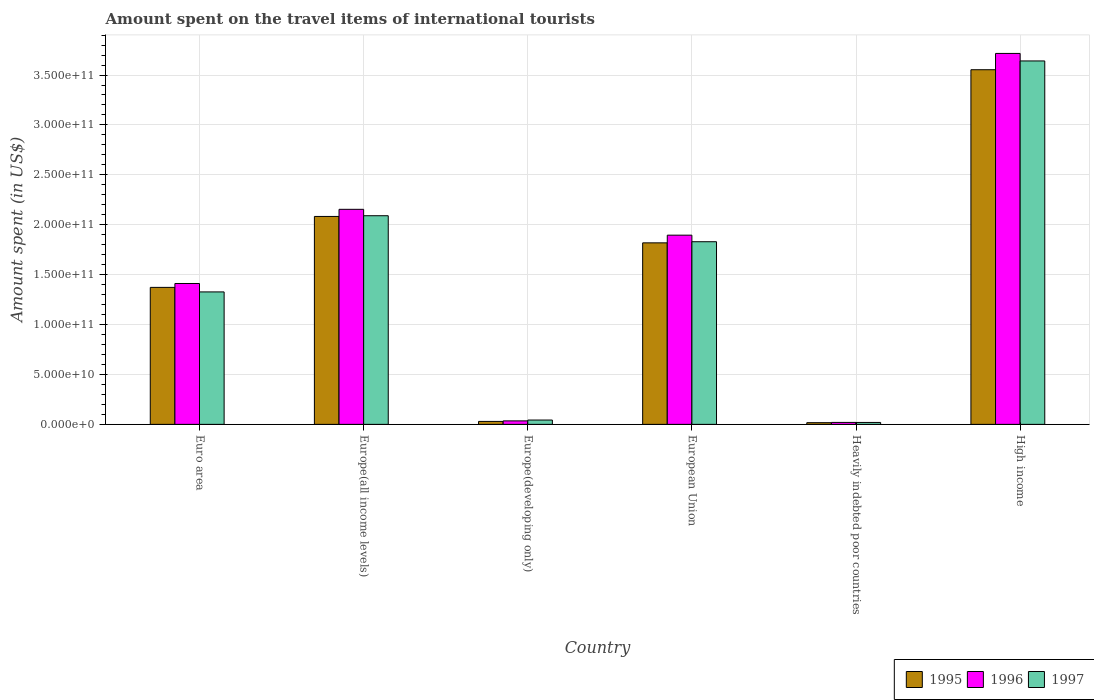How many different coloured bars are there?
Keep it short and to the point. 3. How many groups of bars are there?
Offer a very short reply. 6. How many bars are there on the 3rd tick from the right?
Offer a terse response. 3. In how many cases, is the number of bars for a given country not equal to the number of legend labels?
Keep it short and to the point. 0. What is the amount spent on the travel items of international tourists in 1995 in European Union?
Offer a very short reply. 1.82e+11. Across all countries, what is the maximum amount spent on the travel items of international tourists in 1996?
Offer a very short reply. 3.72e+11. Across all countries, what is the minimum amount spent on the travel items of international tourists in 1997?
Provide a succinct answer. 1.94e+09. In which country was the amount spent on the travel items of international tourists in 1996 maximum?
Provide a short and direct response. High income. In which country was the amount spent on the travel items of international tourists in 1996 minimum?
Your answer should be compact. Heavily indebted poor countries. What is the total amount spent on the travel items of international tourists in 1997 in the graph?
Your answer should be compact. 8.95e+11. What is the difference between the amount spent on the travel items of international tourists in 1997 in Europe(developing only) and that in European Union?
Your answer should be compact. -1.79e+11. What is the difference between the amount spent on the travel items of international tourists in 1995 in Europe(developing only) and the amount spent on the travel items of international tourists in 1996 in Europe(all income levels)?
Make the answer very short. -2.12e+11. What is the average amount spent on the travel items of international tourists in 1995 per country?
Make the answer very short. 1.48e+11. What is the difference between the amount spent on the travel items of international tourists of/in 1996 and amount spent on the travel items of international tourists of/in 1997 in Euro area?
Ensure brevity in your answer.  8.44e+09. What is the ratio of the amount spent on the travel items of international tourists in 1995 in Euro area to that in Europe(developing only)?
Provide a short and direct response. 46.21. What is the difference between the highest and the second highest amount spent on the travel items of international tourists in 1995?
Ensure brevity in your answer.  -1.73e+11. What is the difference between the highest and the lowest amount spent on the travel items of international tourists in 1995?
Give a very brief answer. 3.54e+11. Is the sum of the amount spent on the travel items of international tourists in 1996 in Europe(all income levels) and Heavily indebted poor countries greater than the maximum amount spent on the travel items of international tourists in 1997 across all countries?
Your answer should be very brief. No. What does the 1st bar from the left in Europe(all income levels) represents?
Offer a terse response. 1995. What does the 3rd bar from the right in High income represents?
Your answer should be compact. 1995. Is it the case that in every country, the sum of the amount spent on the travel items of international tourists in 1997 and amount spent on the travel items of international tourists in 1995 is greater than the amount spent on the travel items of international tourists in 1996?
Offer a very short reply. Yes. How many bars are there?
Make the answer very short. 18. How many countries are there in the graph?
Make the answer very short. 6. Does the graph contain any zero values?
Make the answer very short. No. Where does the legend appear in the graph?
Your answer should be compact. Bottom right. What is the title of the graph?
Keep it short and to the point. Amount spent on the travel items of international tourists. What is the label or title of the X-axis?
Offer a very short reply. Country. What is the label or title of the Y-axis?
Your answer should be very brief. Amount spent (in US$). What is the Amount spent (in US$) of 1995 in Euro area?
Offer a very short reply. 1.37e+11. What is the Amount spent (in US$) in 1996 in Euro area?
Ensure brevity in your answer.  1.41e+11. What is the Amount spent (in US$) of 1997 in Euro area?
Offer a terse response. 1.33e+11. What is the Amount spent (in US$) in 1995 in Europe(all income levels)?
Offer a very short reply. 2.08e+11. What is the Amount spent (in US$) in 1996 in Europe(all income levels)?
Your response must be concise. 2.15e+11. What is the Amount spent (in US$) of 1997 in Europe(all income levels)?
Ensure brevity in your answer.  2.09e+11. What is the Amount spent (in US$) of 1995 in Europe(developing only)?
Your answer should be compact. 2.97e+09. What is the Amount spent (in US$) of 1996 in Europe(developing only)?
Provide a short and direct response. 3.49e+09. What is the Amount spent (in US$) in 1997 in Europe(developing only)?
Keep it short and to the point. 4.34e+09. What is the Amount spent (in US$) in 1995 in European Union?
Offer a very short reply. 1.82e+11. What is the Amount spent (in US$) of 1996 in European Union?
Offer a very short reply. 1.90e+11. What is the Amount spent (in US$) in 1997 in European Union?
Keep it short and to the point. 1.83e+11. What is the Amount spent (in US$) of 1995 in Heavily indebted poor countries?
Make the answer very short. 1.70e+09. What is the Amount spent (in US$) in 1996 in Heavily indebted poor countries?
Give a very brief answer. 1.97e+09. What is the Amount spent (in US$) in 1997 in Heavily indebted poor countries?
Provide a short and direct response. 1.94e+09. What is the Amount spent (in US$) of 1995 in High income?
Offer a very short reply. 3.55e+11. What is the Amount spent (in US$) in 1996 in High income?
Keep it short and to the point. 3.72e+11. What is the Amount spent (in US$) of 1997 in High income?
Offer a very short reply. 3.64e+11. Across all countries, what is the maximum Amount spent (in US$) in 1995?
Your response must be concise. 3.55e+11. Across all countries, what is the maximum Amount spent (in US$) in 1996?
Offer a terse response. 3.72e+11. Across all countries, what is the maximum Amount spent (in US$) of 1997?
Your response must be concise. 3.64e+11. Across all countries, what is the minimum Amount spent (in US$) in 1995?
Your response must be concise. 1.70e+09. Across all countries, what is the minimum Amount spent (in US$) in 1996?
Offer a very short reply. 1.97e+09. Across all countries, what is the minimum Amount spent (in US$) of 1997?
Offer a very short reply. 1.94e+09. What is the total Amount spent (in US$) in 1995 in the graph?
Provide a succinct answer. 8.87e+11. What is the total Amount spent (in US$) in 1996 in the graph?
Provide a succinct answer. 9.23e+11. What is the total Amount spent (in US$) of 1997 in the graph?
Keep it short and to the point. 8.95e+11. What is the difference between the Amount spent (in US$) in 1995 in Euro area and that in Europe(all income levels)?
Offer a very short reply. -7.11e+1. What is the difference between the Amount spent (in US$) in 1996 in Euro area and that in Europe(all income levels)?
Make the answer very short. -7.43e+1. What is the difference between the Amount spent (in US$) of 1997 in Euro area and that in Europe(all income levels)?
Ensure brevity in your answer.  -7.63e+1. What is the difference between the Amount spent (in US$) of 1995 in Euro area and that in Europe(developing only)?
Ensure brevity in your answer.  1.34e+11. What is the difference between the Amount spent (in US$) of 1996 in Euro area and that in Europe(developing only)?
Offer a terse response. 1.38e+11. What is the difference between the Amount spent (in US$) in 1997 in Euro area and that in Europe(developing only)?
Provide a short and direct response. 1.28e+11. What is the difference between the Amount spent (in US$) of 1995 in Euro area and that in European Union?
Offer a terse response. -4.46e+1. What is the difference between the Amount spent (in US$) in 1996 in Euro area and that in European Union?
Ensure brevity in your answer.  -4.84e+1. What is the difference between the Amount spent (in US$) in 1997 in Euro area and that in European Union?
Provide a short and direct response. -5.03e+1. What is the difference between the Amount spent (in US$) in 1995 in Euro area and that in Heavily indebted poor countries?
Your answer should be compact. 1.36e+11. What is the difference between the Amount spent (in US$) of 1996 in Euro area and that in Heavily indebted poor countries?
Your answer should be compact. 1.39e+11. What is the difference between the Amount spent (in US$) of 1997 in Euro area and that in Heavily indebted poor countries?
Your answer should be compact. 1.31e+11. What is the difference between the Amount spent (in US$) in 1995 in Euro area and that in High income?
Provide a succinct answer. -2.18e+11. What is the difference between the Amount spent (in US$) in 1996 in Euro area and that in High income?
Offer a very short reply. -2.30e+11. What is the difference between the Amount spent (in US$) in 1997 in Euro area and that in High income?
Provide a short and direct response. -2.31e+11. What is the difference between the Amount spent (in US$) in 1995 in Europe(all income levels) and that in Europe(developing only)?
Offer a terse response. 2.05e+11. What is the difference between the Amount spent (in US$) in 1996 in Europe(all income levels) and that in Europe(developing only)?
Provide a succinct answer. 2.12e+11. What is the difference between the Amount spent (in US$) of 1997 in Europe(all income levels) and that in Europe(developing only)?
Provide a succinct answer. 2.05e+11. What is the difference between the Amount spent (in US$) in 1995 in Europe(all income levels) and that in European Union?
Your answer should be very brief. 2.65e+1. What is the difference between the Amount spent (in US$) in 1996 in Europe(all income levels) and that in European Union?
Provide a succinct answer. 2.59e+1. What is the difference between the Amount spent (in US$) of 1997 in Europe(all income levels) and that in European Union?
Provide a short and direct response. 2.61e+1. What is the difference between the Amount spent (in US$) of 1995 in Europe(all income levels) and that in Heavily indebted poor countries?
Provide a short and direct response. 2.07e+11. What is the difference between the Amount spent (in US$) in 1996 in Europe(all income levels) and that in Heavily indebted poor countries?
Offer a very short reply. 2.13e+11. What is the difference between the Amount spent (in US$) of 1997 in Europe(all income levels) and that in Heavily indebted poor countries?
Give a very brief answer. 2.07e+11. What is the difference between the Amount spent (in US$) in 1995 in Europe(all income levels) and that in High income?
Offer a very short reply. -1.47e+11. What is the difference between the Amount spent (in US$) of 1996 in Europe(all income levels) and that in High income?
Give a very brief answer. -1.56e+11. What is the difference between the Amount spent (in US$) of 1997 in Europe(all income levels) and that in High income?
Give a very brief answer. -1.55e+11. What is the difference between the Amount spent (in US$) in 1995 in Europe(developing only) and that in European Union?
Offer a very short reply. -1.79e+11. What is the difference between the Amount spent (in US$) in 1996 in Europe(developing only) and that in European Union?
Your response must be concise. -1.86e+11. What is the difference between the Amount spent (in US$) in 1997 in Europe(developing only) and that in European Union?
Your answer should be compact. -1.79e+11. What is the difference between the Amount spent (in US$) in 1995 in Europe(developing only) and that in Heavily indebted poor countries?
Keep it short and to the point. 1.27e+09. What is the difference between the Amount spent (in US$) in 1996 in Europe(developing only) and that in Heavily indebted poor countries?
Your answer should be very brief. 1.53e+09. What is the difference between the Amount spent (in US$) in 1997 in Europe(developing only) and that in Heavily indebted poor countries?
Ensure brevity in your answer.  2.41e+09. What is the difference between the Amount spent (in US$) of 1995 in Europe(developing only) and that in High income?
Keep it short and to the point. -3.52e+11. What is the difference between the Amount spent (in US$) of 1996 in Europe(developing only) and that in High income?
Keep it short and to the point. -3.68e+11. What is the difference between the Amount spent (in US$) of 1997 in Europe(developing only) and that in High income?
Your answer should be very brief. -3.60e+11. What is the difference between the Amount spent (in US$) in 1995 in European Union and that in Heavily indebted poor countries?
Give a very brief answer. 1.80e+11. What is the difference between the Amount spent (in US$) of 1996 in European Union and that in Heavily indebted poor countries?
Offer a terse response. 1.88e+11. What is the difference between the Amount spent (in US$) of 1997 in European Union and that in Heavily indebted poor countries?
Provide a succinct answer. 1.81e+11. What is the difference between the Amount spent (in US$) in 1995 in European Union and that in High income?
Ensure brevity in your answer.  -1.73e+11. What is the difference between the Amount spent (in US$) in 1996 in European Union and that in High income?
Your answer should be very brief. -1.82e+11. What is the difference between the Amount spent (in US$) in 1997 in European Union and that in High income?
Your answer should be compact. -1.81e+11. What is the difference between the Amount spent (in US$) in 1995 in Heavily indebted poor countries and that in High income?
Give a very brief answer. -3.54e+11. What is the difference between the Amount spent (in US$) in 1996 in Heavily indebted poor countries and that in High income?
Make the answer very short. -3.70e+11. What is the difference between the Amount spent (in US$) of 1997 in Heavily indebted poor countries and that in High income?
Make the answer very short. -3.62e+11. What is the difference between the Amount spent (in US$) of 1995 in Euro area and the Amount spent (in US$) of 1996 in Europe(all income levels)?
Your answer should be compact. -7.82e+1. What is the difference between the Amount spent (in US$) of 1995 in Euro area and the Amount spent (in US$) of 1997 in Europe(all income levels)?
Provide a succinct answer. -7.18e+1. What is the difference between the Amount spent (in US$) in 1996 in Euro area and the Amount spent (in US$) in 1997 in Europe(all income levels)?
Your response must be concise. -6.79e+1. What is the difference between the Amount spent (in US$) in 1995 in Euro area and the Amount spent (in US$) in 1996 in Europe(developing only)?
Provide a succinct answer. 1.34e+11. What is the difference between the Amount spent (in US$) in 1995 in Euro area and the Amount spent (in US$) in 1997 in Europe(developing only)?
Provide a short and direct response. 1.33e+11. What is the difference between the Amount spent (in US$) in 1996 in Euro area and the Amount spent (in US$) in 1997 in Europe(developing only)?
Provide a short and direct response. 1.37e+11. What is the difference between the Amount spent (in US$) of 1995 in Euro area and the Amount spent (in US$) of 1996 in European Union?
Your answer should be compact. -5.23e+1. What is the difference between the Amount spent (in US$) in 1995 in Euro area and the Amount spent (in US$) in 1997 in European Union?
Your answer should be compact. -4.57e+1. What is the difference between the Amount spent (in US$) in 1996 in Euro area and the Amount spent (in US$) in 1997 in European Union?
Provide a succinct answer. -4.18e+1. What is the difference between the Amount spent (in US$) in 1995 in Euro area and the Amount spent (in US$) in 1996 in Heavily indebted poor countries?
Offer a terse response. 1.35e+11. What is the difference between the Amount spent (in US$) of 1995 in Euro area and the Amount spent (in US$) of 1997 in Heavily indebted poor countries?
Make the answer very short. 1.35e+11. What is the difference between the Amount spent (in US$) of 1996 in Euro area and the Amount spent (in US$) of 1997 in Heavily indebted poor countries?
Your answer should be compact. 1.39e+11. What is the difference between the Amount spent (in US$) of 1995 in Euro area and the Amount spent (in US$) of 1996 in High income?
Offer a very short reply. -2.34e+11. What is the difference between the Amount spent (in US$) of 1995 in Euro area and the Amount spent (in US$) of 1997 in High income?
Ensure brevity in your answer.  -2.27e+11. What is the difference between the Amount spent (in US$) in 1996 in Euro area and the Amount spent (in US$) in 1997 in High income?
Your answer should be very brief. -2.23e+11. What is the difference between the Amount spent (in US$) of 1995 in Europe(all income levels) and the Amount spent (in US$) of 1996 in Europe(developing only)?
Offer a terse response. 2.05e+11. What is the difference between the Amount spent (in US$) in 1995 in Europe(all income levels) and the Amount spent (in US$) in 1997 in Europe(developing only)?
Your answer should be compact. 2.04e+11. What is the difference between the Amount spent (in US$) in 1996 in Europe(all income levels) and the Amount spent (in US$) in 1997 in Europe(developing only)?
Make the answer very short. 2.11e+11. What is the difference between the Amount spent (in US$) in 1995 in Europe(all income levels) and the Amount spent (in US$) in 1996 in European Union?
Keep it short and to the point. 1.88e+1. What is the difference between the Amount spent (in US$) of 1995 in Europe(all income levels) and the Amount spent (in US$) of 1997 in European Union?
Offer a terse response. 2.53e+1. What is the difference between the Amount spent (in US$) in 1996 in Europe(all income levels) and the Amount spent (in US$) in 1997 in European Union?
Offer a very short reply. 3.25e+1. What is the difference between the Amount spent (in US$) of 1995 in Europe(all income levels) and the Amount spent (in US$) of 1996 in Heavily indebted poor countries?
Make the answer very short. 2.06e+11. What is the difference between the Amount spent (in US$) of 1995 in Europe(all income levels) and the Amount spent (in US$) of 1997 in Heavily indebted poor countries?
Your response must be concise. 2.06e+11. What is the difference between the Amount spent (in US$) of 1996 in Europe(all income levels) and the Amount spent (in US$) of 1997 in Heavily indebted poor countries?
Your answer should be very brief. 2.14e+11. What is the difference between the Amount spent (in US$) of 1995 in Europe(all income levels) and the Amount spent (in US$) of 1996 in High income?
Your answer should be very brief. -1.63e+11. What is the difference between the Amount spent (in US$) in 1995 in Europe(all income levels) and the Amount spent (in US$) in 1997 in High income?
Give a very brief answer. -1.56e+11. What is the difference between the Amount spent (in US$) of 1996 in Europe(all income levels) and the Amount spent (in US$) of 1997 in High income?
Provide a succinct answer. -1.49e+11. What is the difference between the Amount spent (in US$) of 1995 in Europe(developing only) and the Amount spent (in US$) of 1996 in European Union?
Your response must be concise. -1.87e+11. What is the difference between the Amount spent (in US$) of 1995 in Europe(developing only) and the Amount spent (in US$) of 1997 in European Union?
Your response must be concise. -1.80e+11. What is the difference between the Amount spent (in US$) of 1996 in Europe(developing only) and the Amount spent (in US$) of 1997 in European Union?
Keep it short and to the point. -1.79e+11. What is the difference between the Amount spent (in US$) in 1995 in Europe(developing only) and the Amount spent (in US$) in 1996 in Heavily indebted poor countries?
Offer a terse response. 1.00e+09. What is the difference between the Amount spent (in US$) of 1995 in Europe(developing only) and the Amount spent (in US$) of 1997 in Heavily indebted poor countries?
Your answer should be very brief. 1.03e+09. What is the difference between the Amount spent (in US$) in 1996 in Europe(developing only) and the Amount spent (in US$) in 1997 in Heavily indebted poor countries?
Provide a succinct answer. 1.56e+09. What is the difference between the Amount spent (in US$) in 1995 in Europe(developing only) and the Amount spent (in US$) in 1996 in High income?
Offer a very short reply. -3.69e+11. What is the difference between the Amount spent (in US$) in 1995 in Europe(developing only) and the Amount spent (in US$) in 1997 in High income?
Give a very brief answer. -3.61e+11. What is the difference between the Amount spent (in US$) in 1996 in Europe(developing only) and the Amount spent (in US$) in 1997 in High income?
Your answer should be very brief. -3.61e+11. What is the difference between the Amount spent (in US$) of 1995 in European Union and the Amount spent (in US$) of 1996 in Heavily indebted poor countries?
Make the answer very short. 1.80e+11. What is the difference between the Amount spent (in US$) in 1995 in European Union and the Amount spent (in US$) in 1997 in Heavily indebted poor countries?
Offer a very short reply. 1.80e+11. What is the difference between the Amount spent (in US$) in 1996 in European Union and the Amount spent (in US$) in 1997 in Heavily indebted poor countries?
Make the answer very short. 1.88e+11. What is the difference between the Amount spent (in US$) of 1995 in European Union and the Amount spent (in US$) of 1996 in High income?
Your response must be concise. -1.90e+11. What is the difference between the Amount spent (in US$) in 1995 in European Union and the Amount spent (in US$) in 1997 in High income?
Your answer should be very brief. -1.82e+11. What is the difference between the Amount spent (in US$) of 1996 in European Union and the Amount spent (in US$) of 1997 in High income?
Keep it short and to the point. -1.75e+11. What is the difference between the Amount spent (in US$) of 1995 in Heavily indebted poor countries and the Amount spent (in US$) of 1996 in High income?
Provide a short and direct response. -3.70e+11. What is the difference between the Amount spent (in US$) in 1995 in Heavily indebted poor countries and the Amount spent (in US$) in 1997 in High income?
Give a very brief answer. -3.62e+11. What is the difference between the Amount spent (in US$) in 1996 in Heavily indebted poor countries and the Amount spent (in US$) in 1997 in High income?
Keep it short and to the point. -3.62e+11. What is the average Amount spent (in US$) of 1995 per country?
Provide a short and direct response. 1.48e+11. What is the average Amount spent (in US$) of 1996 per country?
Keep it short and to the point. 1.54e+11. What is the average Amount spent (in US$) of 1997 per country?
Give a very brief answer. 1.49e+11. What is the difference between the Amount spent (in US$) of 1995 and Amount spent (in US$) of 1996 in Euro area?
Your answer should be compact. -3.90e+09. What is the difference between the Amount spent (in US$) in 1995 and Amount spent (in US$) in 1997 in Euro area?
Offer a terse response. 4.54e+09. What is the difference between the Amount spent (in US$) of 1996 and Amount spent (in US$) of 1997 in Euro area?
Your answer should be compact. 8.44e+09. What is the difference between the Amount spent (in US$) in 1995 and Amount spent (in US$) in 1996 in Europe(all income levels)?
Provide a short and direct response. -7.14e+09. What is the difference between the Amount spent (in US$) in 1995 and Amount spent (in US$) in 1997 in Europe(all income levels)?
Make the answer very short. -7.16e+08. What is the difference between the Amount spent (in US$) in 1996 and Amount spent (in US$) in 1997 in Europe(all income levels)?
Keep it short and to the point. 6.43e+09. What is the difference between the Amount spent (in US$) of 1995 and Amount spent (in US$) of 1996 in Europe(developing only)?
Your response must be concise. -5.24e+08. What is the difference between the Amount spent (in US$) of 1995 and Amount spent (in US$) of 1997 in Europe(developing only)?
Give a very brief answer. -1.37e+09. What is the difference between the Amount spent (in US$) of 1996 and Amount spent (in US$) of 1997 in Europe(developing only)?
Make the answer very short. -8.50e+08. What is the difference between the Amount spent (in US$) of 1995 and Amount spent (in US$) of 1996 in European Union?
Offer a terse response. -7.70e+09. What is the difference between the Amount spent (in US$) of 1995 and Amount spent (in US$) of 1997 in European Union?
Make the answer very short. -1.12e+09. What is the difference between the Amount spent (in US$) in 1996 and Amount spent (in US$) in 1997 in European Union?
Offer a very short reply. 6.58e+09. What is the difference between the Amount spent (in US$) in 1995 and Amount spent (in US$) in 1996 in Heavily indebted poor countries?
Your response must be concise. -2.62e+08. What is the difference between the Amount spent (in US$) of 1995 and Amount spent (in US$) of 1997 in Heavily indebted poor countries?
Offer a very short reply. -2.36e+08. What is the difference between the Amount spent (in US$) in 1996 and Amount spent (in US$) in 1997 in Heavily indebted poor countries?
Ensure brevity in your answer.  2.65e+07. What is the difference between the Amount spent (in US$) in 1995 and Amount spent (in US$) in 1996 in High income?
Offer a terse response. -1.63e+1. What is the difference between the Amount spent (in US$) in 1995 and Amount spent (in US$) in 1997 in High income?
Offer a terse response. -8.79e+09. What is the difference between the Amount spent (in US$) of 1996 and Amount spent (in US$) of 1997 in High income?
Your answer should be compact. 7.54e+09. What is the ratio of the Amount spent (in US$) of 1995 in Euro area to that in Europe(all income levels)?
Give a very brief answer. 0.66. What is the ratio of the Amount spent (in US$) of 1996 in Euro area to that in Europe(all income levels)?
Ensure brevity in your answer.  0.66. What is the ratio of the Amount spent (in US$) of 1997 in Euro area to that in Europe(all income levels)?
Keep it short and to the point. 0.63. What is the ratio of the Amount spent (in US$) of 1995 in Euro area to that in Europe(developing only)?
Offer a very short reply. 46.21. What is the ratio of the Amount spent (in US$) in 1996 in Euro area to that in Europe(developing only)?
Provide a short and direct response. 40.39. What is the ratio of the Amount spent (in US$) in 1997 in Euro area to that in Europe(developing only)?
Your answer should be compact. 30.55. What is the ratio of the Amount spent (in US$) of 1995 in Euro area to that in European Union?
Ensure brevity in your answer.  0.75. What is the ratio of the Amount spent (in US$) in 1996 in Euro area to that in European Union?
Give a very brief answer. 0.74. What is the ratio of the Amount spent (in US$) in 1997 in Euro area to that in European Union?
Keep it short and to the point. 0.73. What is the ratio of the Amount spent (in US$) in 1995 in Euro area to that in Heavily indebted poor countries?
Give a very brief answer. 80.55. What is the ratio of the Amount spent (in US$) in 1996 in Euro area to that in Heavily indebted poor countries?
Ensure brevity in your answer.  71.8. What is the ratio of the Amount spent (in US$) of 1997 in Euro area to that in Heavily indebted poor countries?
Give a very brief answer. 68.43. What is the ratio of the Amount spent (in US$) in 1995 in Euro area to that in High income?
Give a very brief answer. 0.39. What is the ratio of the Amount spent (in US$) of 1996 in Euro area to that in High income?
Provide a succinct answer. 0.38. What is the ratio of the Amount spent (in US$) of 1997 in Euro area to that in High income?
Your answer should be very brief. 0.36. What is the ratio of the Amount spent (in US$) in 1995 in Europe(all income levels) to that in Europe(developing only)?
Provide a succinct answer. 70.13. What is the ratio of the Amount spent (in US$) in 1996 in Europe(all income levels) to that in Europe(developing only)?
Provide a short and direct response. 61.65. What is the ratio of the Amount spent (in US$) of 1997 in Europe(all income levels) to that in Europe(developing only)?
Your answer should be very brief. 48.11. What is the ratio of the Amount spent (in US$) in 1995 in Europe(all income levels) to that in European Union?
Provide a short and direct response. 1.15. What is the ratio of the Amount spent (in US$) of 1996 in Europe(all income levels) to that in European Union?
Your answer should be compact. 1.14. What is the ratio of the Amount spent (in US$) in 1997 in Europe(all income levels) to that in European Union?
Ensure brevity in your answer.  1.14. What is the ratio of the Amount spent (in US$) of 1995 in Europe(all income levels) to that in Heavily indebted poor countries?
Your answer should be compact. 122.26. What is the ratio of the Amount spent (in US$) in 1996 in Europe(all income levels) to that in Heavily indebted poor countries?
Your answer should be very brief. 109.59. What is the ratio of the Amount spent (in US$) of 1997 in Europe(all income levels) to that in Heavily indebted poor countries?
Your response must be concise. 107.78. What is the ratio of the Amount spent (in US$) of 1995 in Europe(all income levels) to that in High income?
Your response must be concise. 0.59. What is the ratio of the Amount spent (in US$) of 1996 in Europe(all income levels) to that in High income?
Give a very brief answer. 0.58. What is the ratio of the Amount spent (in US$) of 1997 in Europe(all income levels) to that in High income?
Keep it short and to the point. 0.57. What is the ratio of the Amount spent (in US$) of 1995 in Europe(developing only) to that in European Union?
Give a very brief answer. 0.02. What is the ratio of the Amount spent (in US$) in 1996 in Europe(developing only) to that in European Union?
Ensure brevity in your answer.  0.02. What is the ratio of the Amount spent (in US$) of 1997 in Europe(developing only) to that in European Union?
Give a very brief answer. 0.02. What is the ratio of the Amount spent (in US$) in 1995 in Europe(developing only) to that in Heavily indebted poor countries?
Ensure brevity in your answer.  1.74. What is the ratio of the Amount spent (in US$) of 1996 in Europe(developing only) to that in Heavily indebted poor countries?
Your answer should be compact. 1.78. What is the ratio of the Amount spent (in US$) of 1997 in Europe(developing only) to that in Heavily indebted poor countries?
Your answer should be compact. 2.24. What is the ratio of the Amount spent (in US$) in 1995 in Europe(developing only) to that in High income?
Your answer should be very brief. 0.01. What is the ratio of the Amount spent (in US$) of 1996 in Europe(developing only) to that in High income?
Offer a terse response. 0.01. What is the ratio of the Amount spent (in US$) of 1997 in Europe(developing only) to that in High income?
Your answer should be compact. 0.01. What is the ratio of the Amount spent (in US$) in 1995 in European Union to that in Heavily indebted poor countries?
Give a very brief answer. 106.73. What is the ratio of the Amount spent (in US$) in 1996 in European Union to that in Heavily indebted poor countries?
Provide a short and direct response. 96.42. What is the ratio of the Amount spent (in US$) of 1997 in European Union to that in Heavily indebted poor countries?
Make the answer very short. 94.35. What is the ratio of the Amount spent (in US$) in 1995 in European Union to that in High income?
Offer a very short reply. 0.51. What is the ratio of the Amount spent (in US$) of 1996 in European Union to that in High income?
Keep it short and to the point. 0.51. What is the ratio of the Amount spent (in US$) of 1997 in European Union to that in High income?
Provide a succinct answer. 0.5. What is the ratio of the Amount spent (in US$) in 1995 in Heavily indebted poor countries to that in High income?
Offer a terse response. 0. What is the ratio of the Amount spent (in US$) of 1996 in Heavily indebted poor countries to that in High income?
Provide a short and direct response. 0.01. What is the ratio of the Amount spent (in US$) of 1997 in Heavily indebted poor countries to that in High income?
Provide a short and direct response. 0.01. What is the difference between the highest and the second highest Amount spent (in US$) in 1995?
Give a very brief answer. 1.47e+11. What is the difference between the highest and the second highest Amount spent (in US$) in 1996?
Your response must be concise. 1.56e+11. What is the difference between the highest and the second highest Amount spent (in US$) of 1997?
Ensure brevity in your answer.  1.55e+11. What is the difference between the highest and the lowest Amount spent (in US$) in 1995?
Your answer should be compact. 3.54e+11. What is the difference between the highest and the lowest Amount spent (in US$) in 1996?
Your answer should be very brief. 3.70e+11. What is the difference between the highest and the lowest Amount spent (in US$) in 1997?
Your answer should be compact. 3.62e+11. 